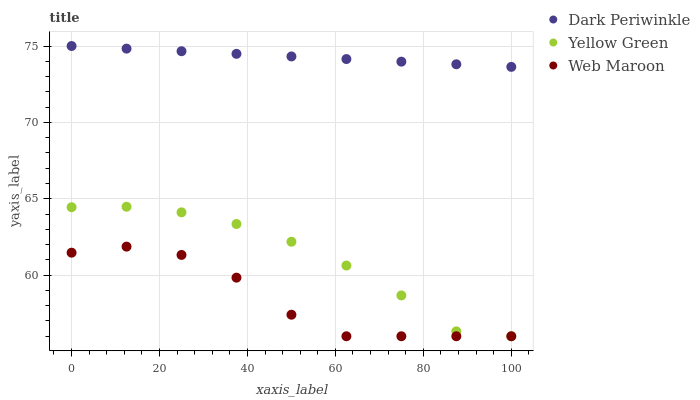Does Web Maroon have the minimum area under the curve?
Answer yes or no. Yes. Does Dark Periwinkle have the maximum area under the curve?
Answer yes or no. Yes. Does Yellow Green have the minimum area under the curve?
Answer yes or no. No. Does Yellow Green have the maximum area under the curve?
Answer yes or no. No. Is Dark Periwinkle the smoothest?
Answer yes or no. Yes. Is Web Maroon the roughest?
Answer yes or no. Yes. Is Yellow Green the smoothest?
Answer yes or no. No. Is Yellow Green the roughest?
Answer yes or no. No. Does Web Maroon have the lowest value?
Answer yes or no. Yes. Does Dark Periwinkle have the lowest value?
Answer yes or no. No. Does Dark Periwinkle have the highest value?
Answer yes or no. Yes. Does Yellow Green have the highest value?
Answer yes or no. No. Is Web Maroon less than Dark Periwinkle?
Answer yes or no. Yes. Is Dark Periwinkle greater than Web Maroon?
Answer yes or no. Yes. Does Web Maroon intersect Yellow Green?
Answer yes or no. Yes. Is Web Maroon less than Yellow Green?
Answer yes or no. No. Is Web Maroon greater than Yellow Green?
Answer yes or no. No. Does Web Maroon intersect Dark Periwinkle?
Answer yes or no. No. 